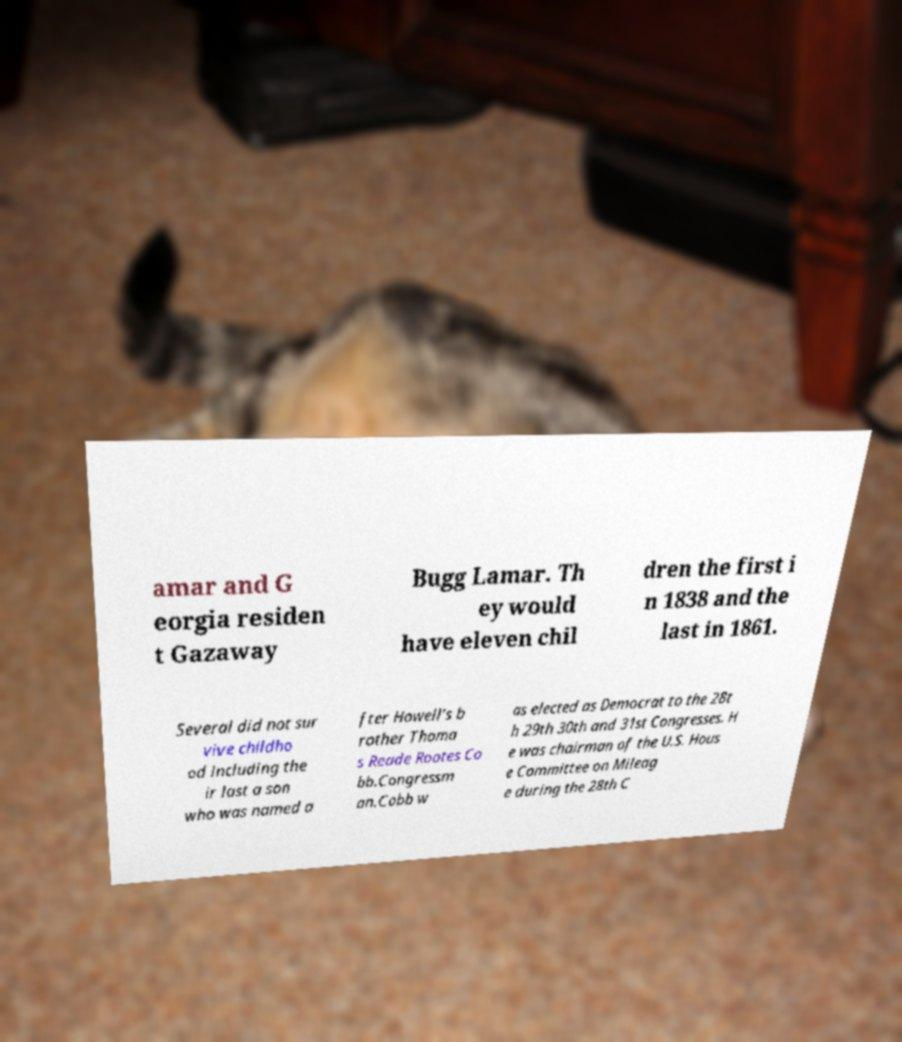Please read and relay the text visible in this image. What does it say? amar and G eorgia residen t Gazaway Bugg Lamar. Th ey would have eleven chil dren the first i n 1838 and the last in 1861. Several did not sur vive childho od including the ir last a son who was named a fter Howell's b rother Thoma s Reade Rootes Co bb.Congressm an.Cobb w as elected as Democrat to the 28t h 29th 30th and 31st Congresses. H e was chairman of the U.S. Hous e Committee on Mileag e during the 28th C 